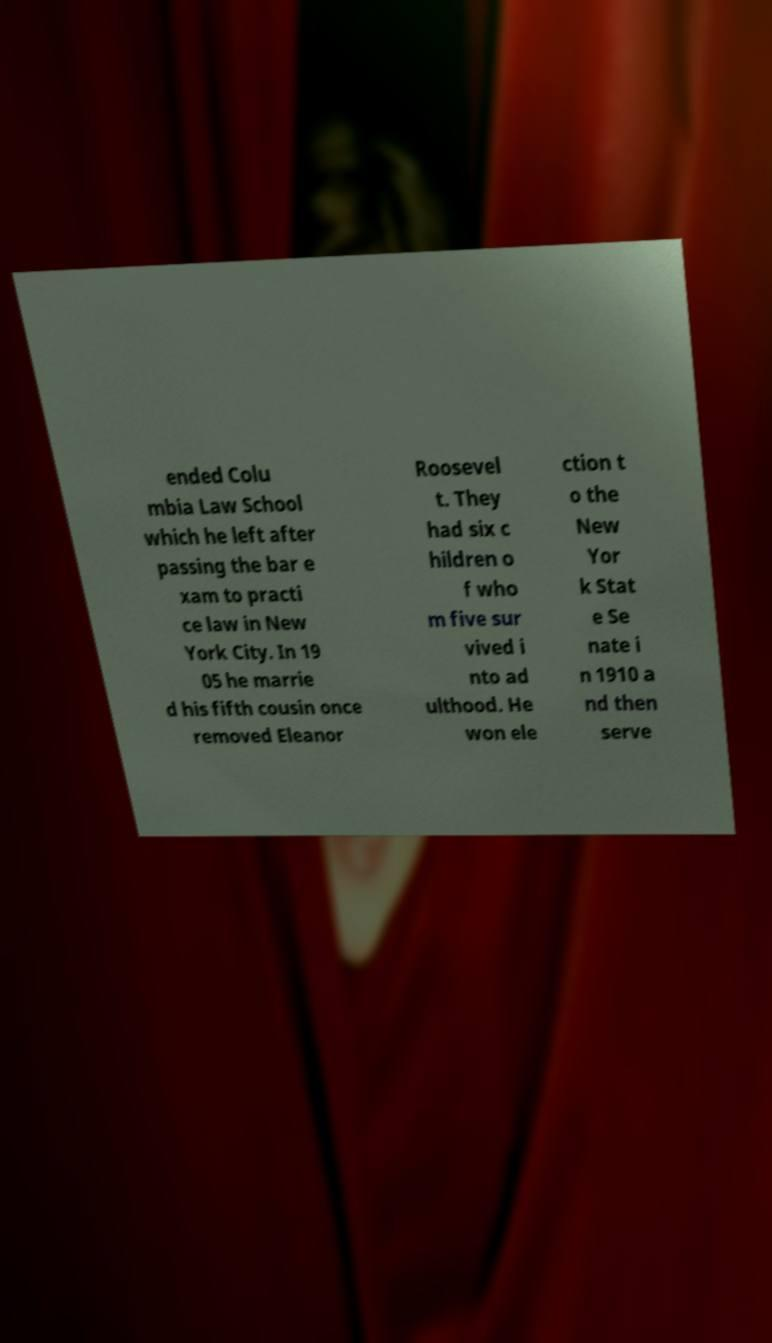There's text embedded in this image that I need extracted. Can you transcribe it verbatim? ended Colu mbia Law School which he left after passing the bar e xam to practi ce law in New York City. In 19 05 he marrie d his fifth cousin once removed Eleanor Roosevel t. They had six c hildren o f who m five sur vived i nto ad ulthood. He won ele ction t o the New Yor k Stat e Se nate i n 1910 a nd then serve 